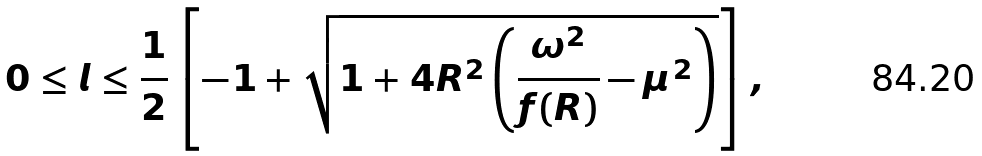Convert formula to latex. <formula><loc_0><loc_0><loc_500><loc_500>0 \leq l \leq \frac { 1 } { 2 } \left [ - 1 + \sqrt { 1 + 4 R ^ { 2 } \left ( \frac { \omega ^ { 2 } } { f ( R ) } - \mu ^ { 2 } \right ) } \right ] ,</formula> 